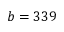<formula> <loc_0><loc_0><loc_500><loc_500>b = 3 3 9</formula> 